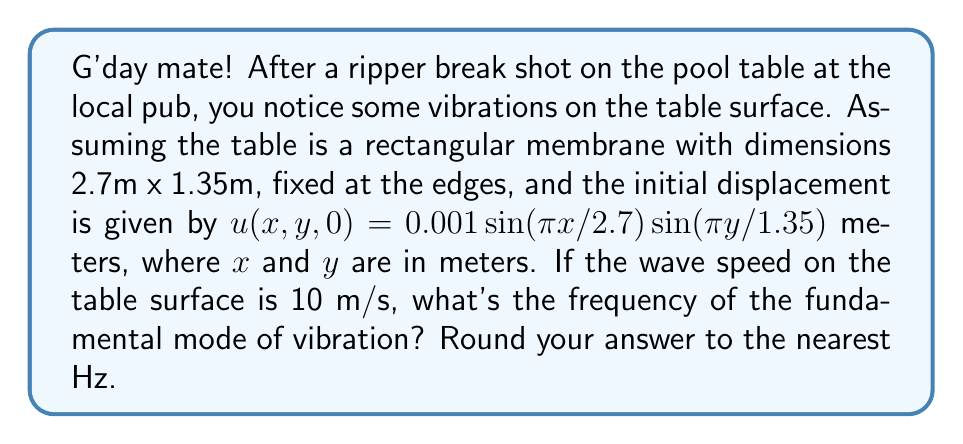What is the answer to this math problem? Alright, let's tackle this step by step, like we're lining up a shot:

1) The wave equation for a rectangular membrane is:

   $$\frac{\partial^2 u}{\partial t^2} = c^2 \left(\frac{\partial^2 u}{\partial x^2} + \frac{\partial^2 u}{\partial y^2}\right)$$

   where $c$ is the wave speed.

2) The general solution for this equation is:

   $$u(x,y,t) = \sum_{m=1}^{\infty}\sum_{n=1}^{\infty} A_{mn} \sin(\frac{m\pi x}{L_x}) \sin(\frac{n\pi y}{L_y}) \cos(\omega_{mn} t)$$

   where $L_x = 2.7$ m and $L_y = 1.35$ m are the dimensions of the table.

3) The frequency $f_{mn}$ is related to $\omega_{mn}$ by:

   $$f_{mn} = \frac{\omega_{mn}}{2\pi} = \frac{c}{2} \sqrt{\left(\frac{m}{L_x}\right)^2 + \left(\frac{n}{L_y}\right)^2}$$

4) The fundamental mode corresponds to $m=1$ and $n=1$. So:

   $$f_{11} = \frac{c}{2} \sqrt{\left(\frac{1}{2.7}\right)^2 + \left(\frac{1}{1.35}\right)^2}$$

5) Plugging in the values:

   $$f_{11} = \frac{10}{2} \sqrt{\left(\frac{1}{2.7}\right)^2 + \left(\frac{1}{1.35}\right)^2}$$

6) Simplifying:

   $$f_{11} = 5 \sqrt{\frac{1}{7.29} + \frac{4}{7.29}} = 5 \sqrt{\frac{5}{7.29}} \approx 4.15 \text{ Hz}$$

7) Rounding to the nearest Hz:

   $$f_{11} \approx 4 \text{ Hz}$$
Answer: 4 Hz 